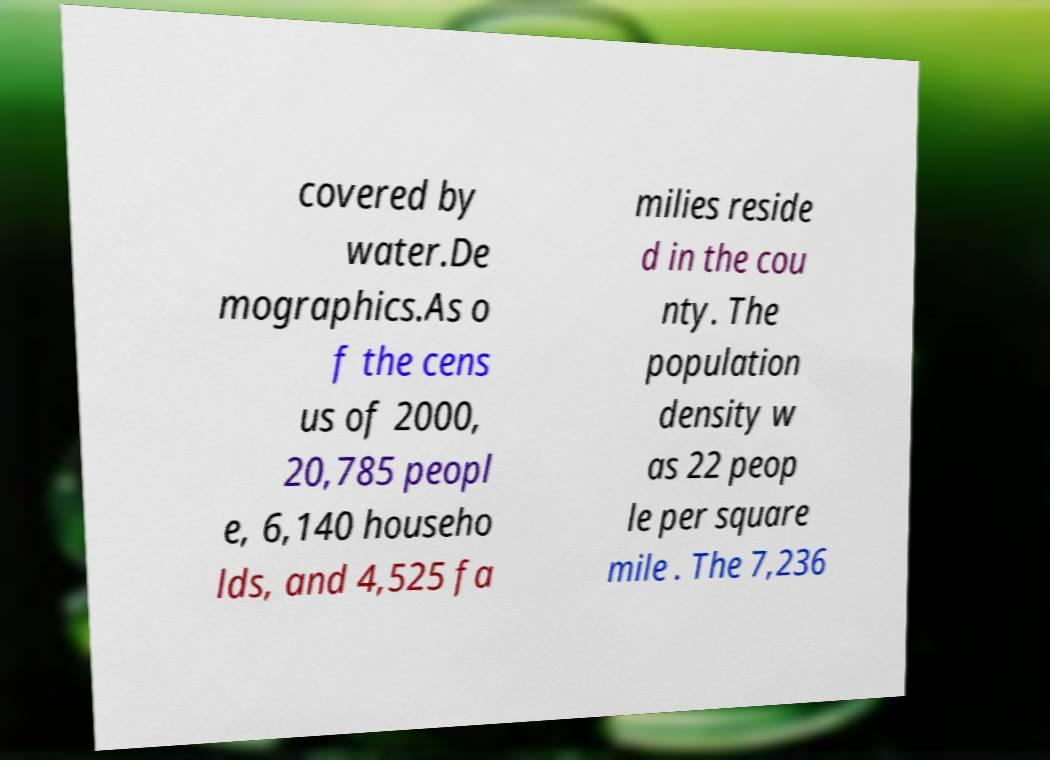What messages or text are displayed in this image? I need them in a readable, typed format. covered by water.De mographics.As o f the cens us of 2000, 20,785 peopl e, 6,140 househo lds, and 4,525 fa milies reside d in the cou nty. The population density w as 22 peop le per square mile . The 7,236 